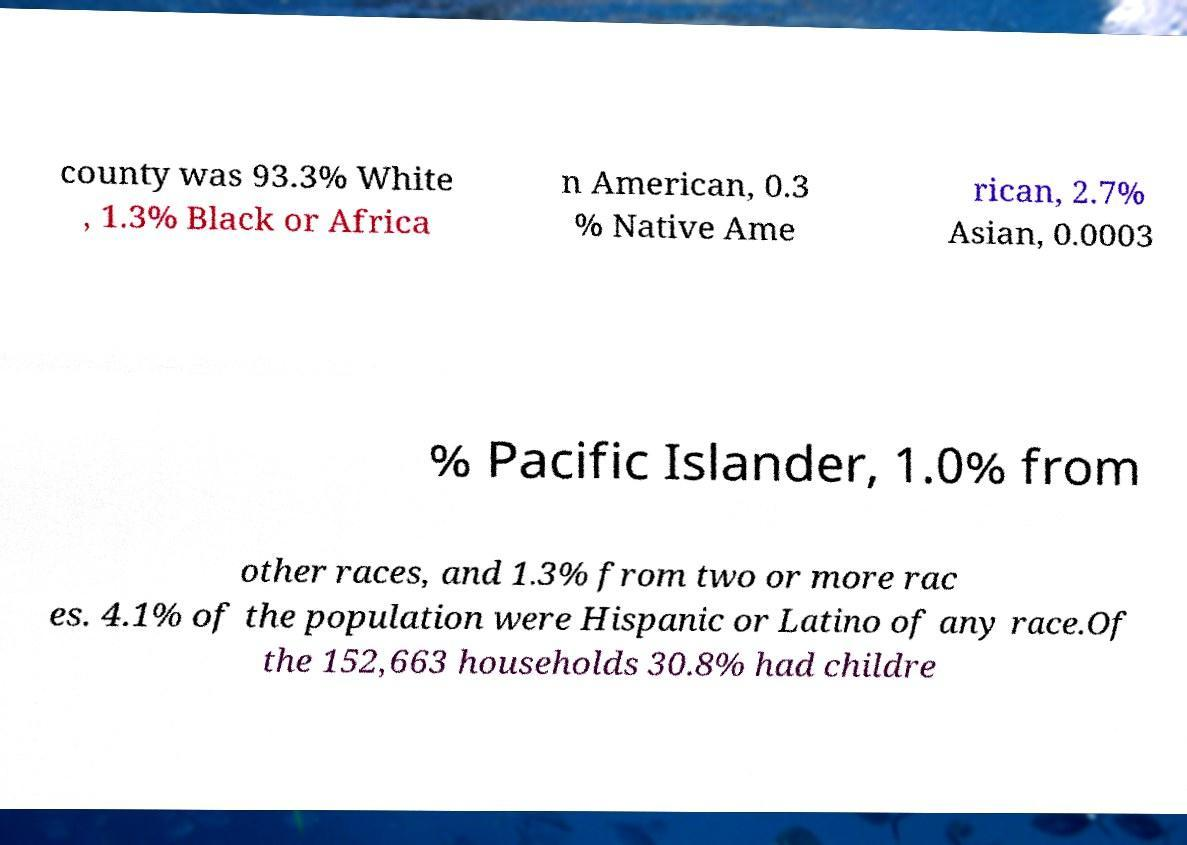Can you accurately transcribe the text from the provided image for me? county was 93.3% White , 1.3% Black or Africa n American, 0.3 % Native Ame rican, 2.7% Asian, 0.0003 % Pacific Islander, 1.0% from other races, and 1.3% from two or more rac es. 4.1% of the population were Hispanic or Latino of any race.Of the 152,663 households 30.8% had childre 